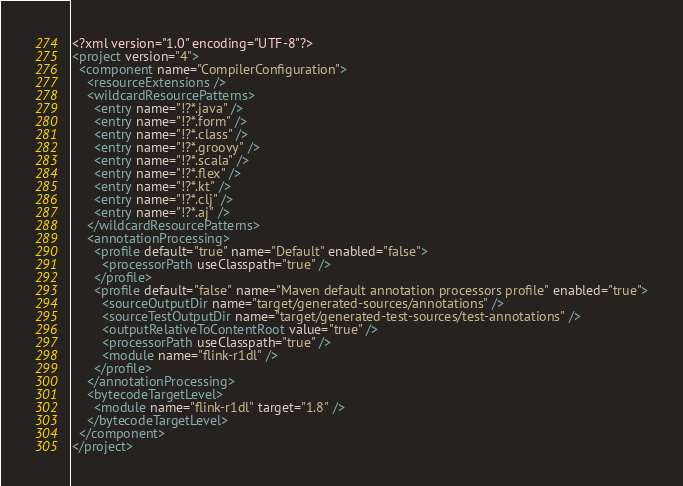<code> <loc_0><loc_0><loc_500><loc_500><_XML_><?xml version="1.0" encoding="UTF-8"?>
<project version="4">
  <component name="CompilerConfiguration">
    <resourceExtensions />
    <wildcardResourcePatterns>
      <entry name="!?*.java" />
      <entry name="!?*.form" />
      <entry name="!?*.class" />
      <entry name="!?*.groovy" />
      <entry name="!?*.scala" />
      <entry name="!?*.flex" />
      <entry name="!?*.kt" />
      <entry name="!?*.clj" />
      <entry name="!?*.aj" />
    </wildcardResourcePatterns>
    <annotationProcessing>
      <profile default="true" name="Default" enabled="false">
        <processorPath useClasspath="true" />
      </profile>
      <profile default="false" name="Maven default annotation processors profile" enabled="true">
        <sourceOutputDir name="target/generated-sources/annotations" />
        <sourceTestOutputDir name="target/generated-test-sources/test-annotations" />
        <outputRelativeToContentRoot value="true" />
        <processorPath useClasspath="true" />
        <module name="flink-r1dl" />
      </profile>
    </annotationProcessing>
    <bytecodeTargetLevel>
      <module name="flink-r1dl" target="1.8" />
    </bytecodeTargetLevel>
  </component>
</project></code> 